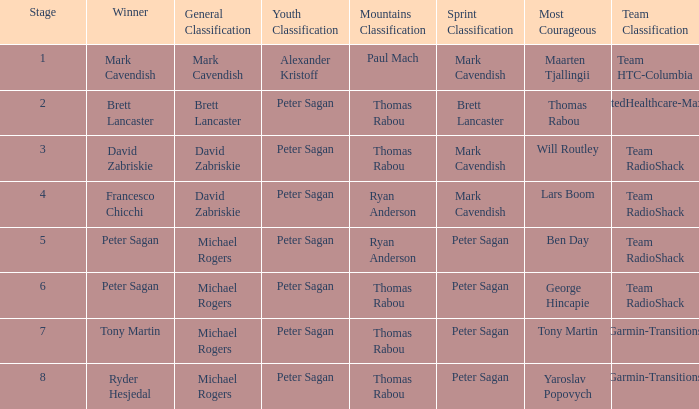Who was the winner of the sprint classification when peter sagan secured the youth classification and thomas rabou claimed the most courageous title? Brett Lancaster. 